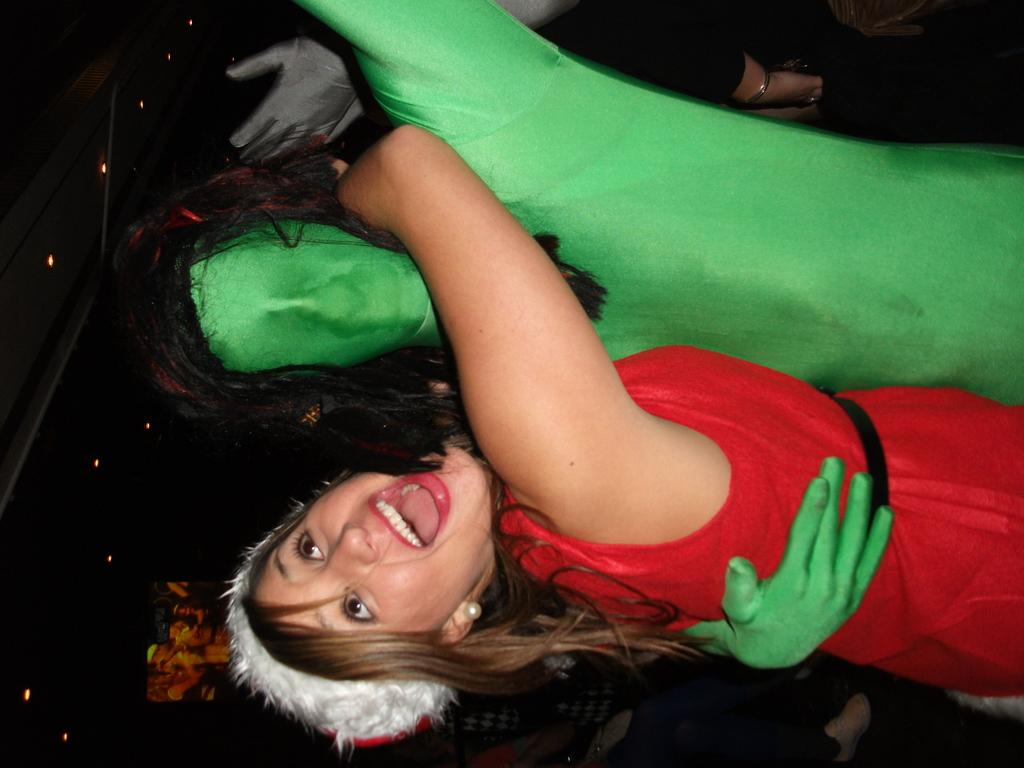What is happening between the two people in the image? There is a person hugging another person in the image. What can be seen in the background of the image? There are other people standing on the floor in the background. What type of lighting is present in the image? There are fall ceiling lights on the roof in the image. Can you tell me how many goldfish are swimming in the image? There are no goldfish present in the image. What type of nose does the person in the image have? The image does not provide enough detail to determine the type of nose the person has. 